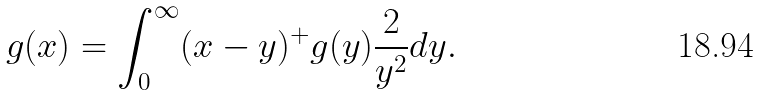Convert formula to latex. <formula><loc_0><loc_0><loc_500><loc_500>g ( x ) = \int _ { 0 } ^ { \infty } ( x - y ) ^ { + } g ( y ) \frac { 2 } { y ^ { 2 } } d y .</formula> 